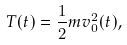<formula> <loc_0><loc_0><loc_500><loc_500>T ( t ) = \frac { 1 } { 2 } m v _ { 0 } ^ { 2 } ( t ) ,</formula> 